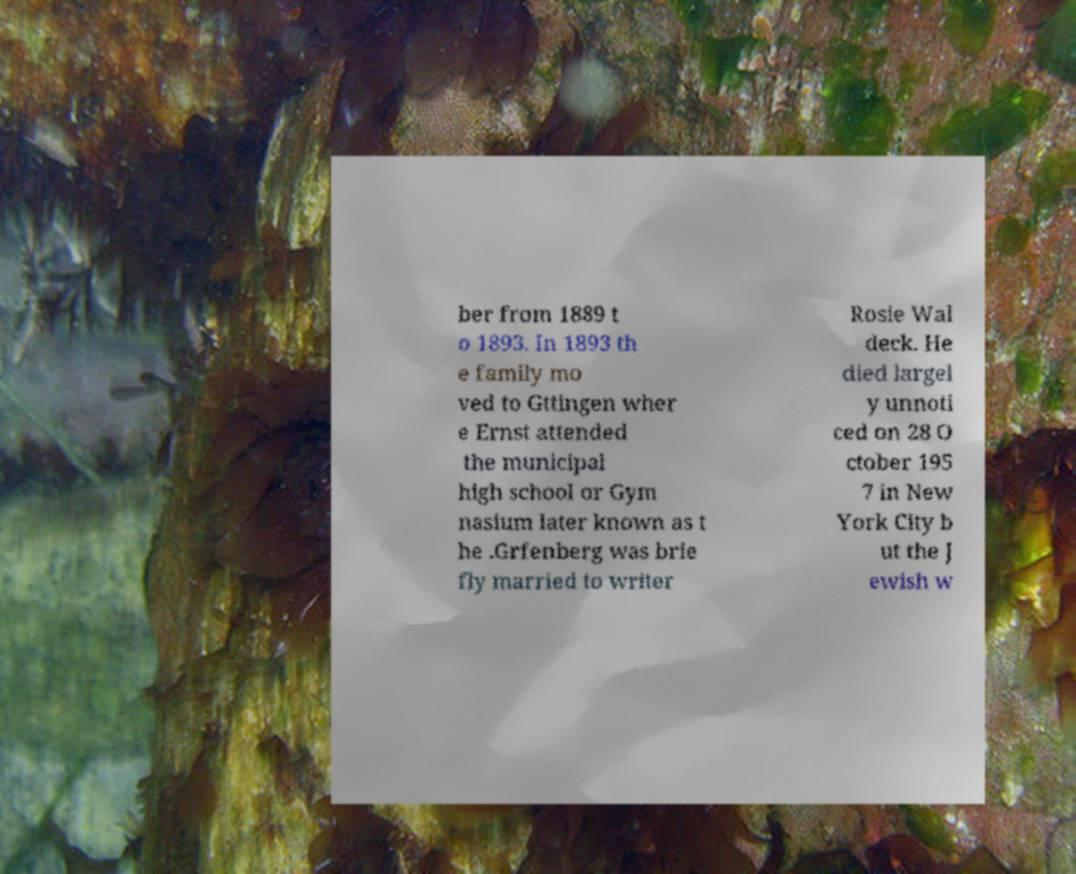Please identify and transcribe the text found in this image. ber from 1889 t o 1893. In 1893 th e family mo ved to Gttingen wher e Ernst attended the municipal high school or Gym nasium later known as t he .Grfenberg was brie fly married to writer Rosie Wal deck. He died largel y unnoti ced on 28 O ctober 195 7 in New York City b ut the J ewish w 